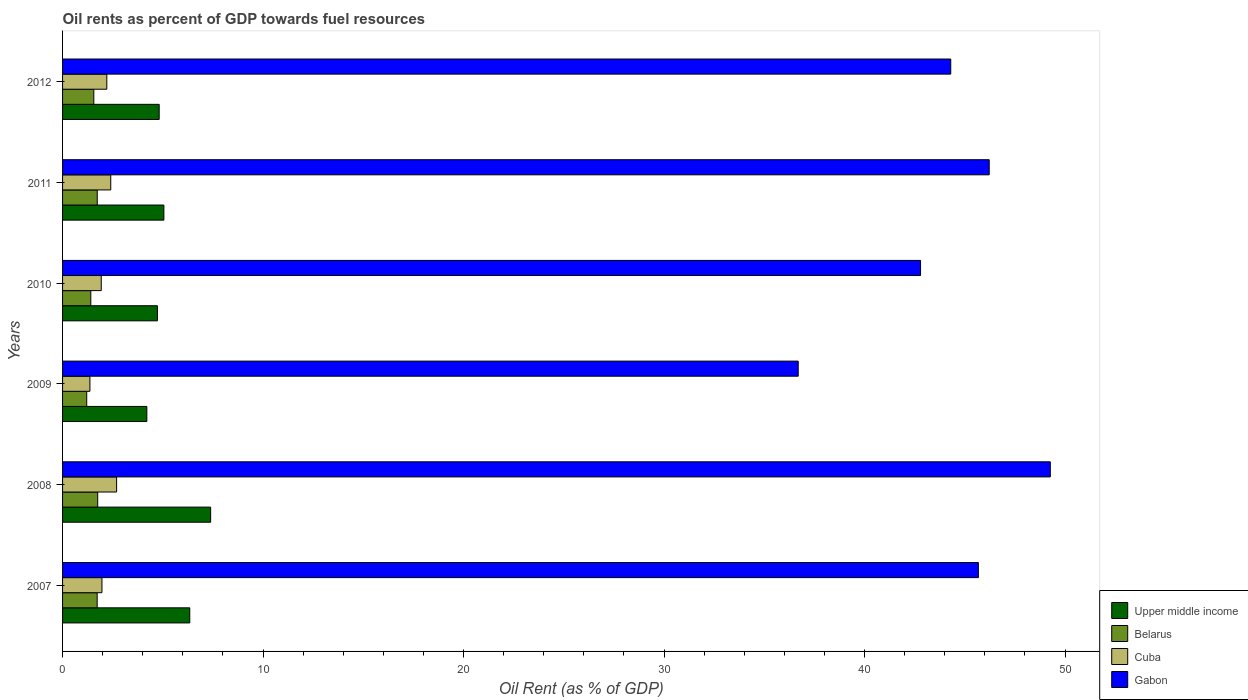How many groups of bars are there?
Offer a terse response. 6. What is the oil rent in Upper middle income in 2010?
Your answer should be very brief. 4.73. Across all years, what is the maximum oil rent in Belarus?
Give a very brief answer. 1.75. Across all years, what is the minimum oil rent in Upper middle income?
Your response must be concise. 4.2. In which year was the oil rent in Cuba maximum?
Offer a very short reply. 2008. What is the total oil rent in Belarus in the graph?
Your response must be concise. 9.38. What is the difference between the oil rent in Belarus in 2010 and that in 2012?
Your answer should be very brief. -0.15. What is the difference between the oil rent in Cuba in 2011 and the oil rent in Belarus in 2008?
Your answer should be very brief. 0.65. What is the average oil rent in Gabon per year?
Your answer should be very brief. 44.16. In the year 2008, what is the difference between the oil rent in Upper middle income and oil rent in Gabon?
Offer a terse response. -41.88. What is the ratio of the oil rent in Gabon in 2009 to that in 2012?
Your answer should be very brief. 0.83. Is the oil rent in Cuba in 2011 less than that in 2012?
Provide a succinct answer. No. What is the difference between the highest and the second highest oil rent in Gabon?
Keep it short and to the point. 3.05. What is the difference between the highest and the lowest oil rent in Upper middle income?
Provide a succinct answer. 3.18. In how many years, is the oil rent in Cuba greater than the average oil rent in Cuba taken over all years?
Provide a short and direct response. 3. Is it the case that in every year, the sum of the oil rent in Cuba and oil rent in Belarus is greater than the sum of oil rent in Upper middle income and oil rent in Gabon?
Make the answer very short. No. What does the 2nd bar from the top in 2007 represents?
Provide a short and direct response. Cuba. What does the 4th bar from the bottom in 2012 represents?
Keep it short and to the point. Gabon. Are all the bars in the graph horizontal?
Offer a terse response. Yes. What is the difference between two consecutive major ticks on the X-axis?
Keep it short and to the point. 10. Are the values on the major ticks of X-axis written in scientific E-notation?
Offer a terse response. No. Does the graph contain any zero values?
Ensure brevity in your answer.  No. Where does the legend appear in the graph?
Your answer should be compact. Bottom right. How are the legend labels stacked?
Provide a short and direct response. Vertical. What is the title of the graph?
Provide a short and direct response. Oil rents as percent of GDP towards fuel resources. Does "New Zealand" appear as one of the legend labels in the graph?
Ensure brevity in your answer.  No. What is the label or title of the X-axis?
Make the answer very short. Oil Rent (as % of GDP). What is the label or title of the Y-axis?
Offer a very short reply. Years. What is the Oil Rent (as % of GDP) in Upper middle income in 2007?
Give a very brief answer. 6.34. What is the Oil Rent (as % of GDP) of Belarus in 2007?
Give a very brief answer. 1.73. What is the Oil Rent (as % of GDP) in Cuba in 2007?
Your answer should be compact. 1.96. What is the Oil Rent (as % of GDP) in Gabon in 2007?
Keep it short and to the point. 45.68. What is the Oil Rent (as % of GDP) of Upper middle income in 2008?
Give a very brief answer. 7.39. What is the Oil Rent (as % of GDP) in Belarus in 2008?
Your answer should be compact. 1.75. What is the Oil Rent (as % of GDP) in Cuba in 2008?
Your answer should be very brief. 2.7. What is the Oil Rent (as % of GDP) in Gabon in 2008?
Provide a succinct answer. 49.26. What is the Oil Rent (as % of GDP) in Upper middle income in 2009?
Your answer should be very brief. 4.2. What is the Oil Rent (as % of GDP) in Belarus in 2009?
Offer a terse response. 1.2. What is the Oil Rent (as % of GDP) of Cuba in 2009?
Your response must be concise. 1.36. What is the Oil Rent (as % of GDP) in Gabon in 2009?
Give a very brief answer. 36.69. What is the Oil Rent (as % of GDP) in Upper middle income in 2010?
Provide a succinct answer. 4.73. What is the Oil Rent (as % of GDP) in Belarus in 2010?
Make the answer very short. 1.41. What is the Oil Rent (as % of GDP) in Cuba in 2010?
Provide a succinct answer. 1.93. What is the Oil Rent (as % of GDP) in Gabon in 2010?
Provide a short and direct response. 42.79. What is the Oil Rent (as % of GDP) in Upper middle income in 2011?
Keep it short and to the point. 5.05. What is the Oil Rent (as % of GDP) in Belarus in 2011?
Offer a very short reply. 1.73. What is the Oil Rent (as % of GDP) in Cuba in 2011?
Your response must be concise. 2.4. What is the Oil Rent (as % of GDP) of Gabon in 2011?
Provide a short and direct response. 46.22. What is the Oil Rent (as % of GDP) in Upper middle income in 2012?
Offer a very short reply. 4.82. What is the Oil Rent (as % of GDP) in Belarus in 2012?
Keep it short and to the point. 1.56. What is the Oil Rent (as % of GDP) in Cuba in 2012?
Offer a terse response. 2.21. What is the Oil Rent (as % of GDP) in Gabon in 2012?
Your answer should be very brief. 44.3. Across all years, what is the maximum Oil Rent (as % of GDP) in Upper middle income?
Your answer should be compact. 7.39. Across all years, what is the maximum Oil Rent (as % of GDP) of Belarus?
Offer a terse response. 1.75. Across all years, what is the maximum Oil Rent (as % of GDP) of Cuba?
Your response must be concise. 2.7. Across all years, what is the maximum Oil Rent (as % of GDP) in Gabon?
Provide a short and direct response. 49.26. Across all years, what is the minimum Oil Rent (as % of GDP) in Upper middle income?
Keep it short and to the point. 4.2. Across all years, what is the minimum Oil Rent (as % of GDP) in Belarus?
Provide a succinct answer. 1.2. Across all years, what is the minimum Oil Rent (as % of GDP) in Cuba?
Keep it short and to the point. 1.36. Across all years, what is the minimum Oil Rent (as % of GDP) in Gabon?
Offer a terse response. 36.69. What is the total Oil Rent (as % of GDP) of Upper middle income in the graph?
Your response must be concise. 32.54. What is the total Oil Rent (as % of GDP) of Belarus in the graph?
Ensure brevity in your answer.  9.38. What is the total Oil Rent (as % of GDP) of Cuba in the graph?
Make the answer very short. 12.56. What is the total Oil Rent (as % of GDP) in Gabon in the graph?
Provide a short and direct response. 264.94. What is the difference between the Oil Rent (as % of GDP) in Upper middle income in 2007 and that in 2008?
Make the answer very short. -1.04. What is the difference between the Oil Rent (as % of GDP) of Belarus in 2007 and that in 2008?
Provide a short and direct response. -0.03. What is the difference between the Oil Rent (as % of GDP) in Cuba in 2007 and that in 2008?
Your response must be concise. -0.73. What is the difference between the Oil Rent (as % of GDP) of Gabon in 2007 and that in 2008?
Your answer should be very brief. -3.59. What is the difference between the Oil Rent (as % of GDP) of Upper middle income in 2007 and that in 2009?
Offer a terse response. 2.14. What is the difference between the Oil Rent (as % of GDP) in Belarus in 2007 and that in 2009?
Your answer should be compact. 0.52. What is the difference between the Oil Rent (as % of GDP) of Cuba in 2007 and that in 2009?
Your answer should be very brief. 0.6. What is the difference between the Oil Rent (as % of GDP) in Gabon in 2007 and that in 2009?
Offer a terse response. 8.99. What is the difference between the Oil Rent (as % of GDP) in Upper middle income in 2007 and that in 2010?
Offer a very short reply. 1.61. What is the difference between the Oil Rent (as % of GDP) of Belarus in 2007 and that in 2010?
Provide a succinct answer. 0.32. What is the difference between the Oil Rent (as % of GDP) in Cuba in 2007 and that in 2010?
Give a very brief answer. 0.03. What is the difference between the Oil Rent (as % of GDP) of Gabon in 2007 and that in 2010?
Provide a succinct answer. 2.88. What is the difference between the Oil Rent (as % of GDP) of Upper middle income in 2007 and that in 2011?
Provide a short and direct response. 1.29. What is the difference between the Oil Rent (as % of GDP) in Belarus in 2007 and that in 2011?
Ensure brevity in your answer.  -0. What is the difference between the Oil Rent (as % of GDP) in Cuba in 2007 and that in 2011?
Your answer should be compact. -0.44. What is the difference between the Oil Rent (as % of GDP) in Gabon in 2007 and that in 2011?
Offer a very short reply. -0.54. What is the difference between the Oil Rent (as % of GDP) of Upper middle income in 2007 and that in 2012?
Offer a terse response. 1.52. What is the difference between the Oil Rent (as % of GDP) of Belarus in 2007 and that in 2012?
Ensure brevity in your answer.  0.17. What is the difference between the Oil Rent (as % of GDP) in Cuba in 2007 and that in 2012?
Provide a succinct answer. -0.24. What is the difference between the Oil Rent (as % of GDP) in Gabon in 2007 and that in 2012?
Make the answer very short. 1.38. What is the difference between the Oil Rent (as % of GDP) in Upper middle income in 2008 and that in 2009?
Ensure brevity in your answer.  3.18. What is the difference between the Oil Rent (as % of GDP) in Belarus in 2008 and that in 2009?
Make the answer very short. 0.55. What is the difference between the Oil Rent (as % of GDP) of Cuba in 2008 and that in 2009?
Keep it short and to the point. 1.33. What is the difference between the Oil Rent (as % of GDP) of Gabon in 2008 and that in 2009?
Offer a very short reply. 12.57. What is the difference between the Oil Rent (as % of GDP) of Upper middle income in 2008 and that in 2010?
Keep it short and to the point. 2.65. What is the difference between the Oil Rent (as % of GDP) in Belarus in 2008 and that in 2010?
Make the answer very short. 0.35. What is the difference between the Oil Rent (as % of GDP) of Cuba in 2008 and that in 2010?
Make the answer very short. 0.77. What is the difference between the Oil Rent (as % of GDP) of Gabon in 2008 and that in 2010?
Your answer should be very brief. 6.47. What is the difference between the Oil Rent (as % of GDP) of Upper middle income in 2008 and that in 2011?
Provide a short and direct response. 2.33. What is the difference between the Oil Rent (as % of GDP) in Belarus in 2008 and that in 2011?
Provide a succinct answer. 0.02. What is the difference between the Oil Rent (as % of GDP) in Cuba in 2008 and that in 2011?
Keep it short and to the point. 0.29. What is the difference between the Oil Rent (as % of GDP) of Gabon in 2008 and that in 2011?
Provide a short and direct response. 3.05. What is the difference between the Oil Rent (as % of GDP) in Upper middle income in 2008 and that in 2012?
Give a very brief answer. 2.57. What is the difference between the Oil Rent (as % of GDP) of Belarus in 2008 and that in 2012?
Provide a short and direct response. 0.19. What is the difference between the Oil Rent (as % of GDP) of Cuba in 2008 and that in 2012?
Offer a terse response. 0.49. What is the difference between the Oil Rent (as % of GDP) in Gabon in 2008 and that in 2012?
Your response must be concise. 4.97. What is the difference between the Oil Rent (as % of GDP) in Upper middle income in 2009 and that in 2010?
Make the answer very short. -0.53. What is the difference between the Oil Rent (as % of GDP) of Belarus in 2009 and that in 2010?
Give a very brief answer. -0.2. What is the difference between the Oil Rent (as % of GDP) of Cuba in 2009 and that in 2010?
Offer a very short reply. -0.57. What is the difference between the Oil Rent (as % of GDP) in Gabon in 2009 and that in 2010?
Your answer should be compact. -6.1. What is the difference between the Oil Rent (as % of GDP) in Upper middle income in 2009 and that in 2011?
Provide a succinct answer. -0.85. What is the difference between the Oil Rent (as % of GDP) in Belarus in 2009 and that in 2011?
Keep it short and to the point. -0.52. What is the difference between the Oil Rent (as % of GDP) of Cuba in 2009 and that in 2011?
Offer a terse response. -1.04. What is the difference between the Oil Rent (as % of GDP) in Gabon in 2009 and that in 2011?
Offer a very short reply. -9.53. What is the difference between the Oil Rent (as % of GDP) in Upper middle income in 2009 and that in 2012?
Provide a succinct answer. -0.62. What is the difference between the Oil Rent (as % of GDP) of Belarus in 2009 and that in 2012?
Provide a short and direct response. -0.35. What is the difference between the Oil Rent (as % of GDP) in Cuba in 2009 and that in 2012?
Keep it short and to the point. -0.84. What is the difference between the Oil Rent (as % of GDP) of Gabon in 2009 and that in 2012?
Your answer should be compact. -7.61. What is the difference between the Oil Rent (as % of GDP) in Upper middle income in 2010 and that in 2011?
Your answer should be very brief. -0.32. What is the difference between the Oil Rent (as % of GDP) of Belarus in 2010 and that in 2011?
Keep it short and to the point. -0.32. What is the difference between the Oil Rent (as % of GDP) of Cuba in 2010 and that in 2011?
Provide a succinct answer. -0.47. What is the difference between the Oil Rent (as % of GDP) of Gabon in 2010 and that in 2011?
Your answer should be very brief. -3.42. What is the difference between the Oil Rent (as % of GDP) in Upper middle income in 2010 and that in 2012?
Make the answer very short. -0.09. What is the difference between the Oil Rent (as % of GDP) of Belarus in 2010 and that in 2012?
Your response must be concise. -0.15. What is the difference between the Oil Rent (as % of GDP) in Cuba in 2010 and that in 2012?
Your answer should be very brief. -0.28. What is the difference between the Oil Rent (as % of GDP) in Gabon in 2010 and that in 2012?
Make the answer very short. -1.51. What is the difference between the Oil Rent (as % of GDP) in Upper middle income in 2011 and that in 2012?
Your answer should be compact. 0.23. What is the difference between the Oil Rent (as % of GDP) of Belarus in 2011 and that in 2012?
Your response must be concise. 0.17. What is the difference between the Oil Rent (as % of GDP) of Cuba in 2011 and that in 2012?
Offer a terse response. 0.2. What is the difference between the Oil Rent (as % of GDP) of Gabon in 2011 and that in 2012?
Ensure brevity in your answer.  1.92. What is the difference between the Oil Rent (as % of GDP) in Upper middle income in 2007 and the Oil Rent (as % of GDP) in Belarus in 2008?
Keep it short and to the point. 4.59. What is the difference between the Oil Rent (as % of GDP) in Upper middle income in 2007 and the Oil Rent (as % of GDP) in Cuba in 2008?
Ensure brevity in your answer.  3.65. What is the difference between the Oil Rent (as % of GDP) of Upper middle income in 2007 and the Oil Rent (as % of GDP) of Gabon in 2008?
Provide a short and direct response. -42.92. What is the difference between the Oil Rent (as % of GDP) in Belarus in 2007 and the Oil Rent (as % of GDP) in Cuba in 2008?
Keep it short and to the point. -0.97. What is the difference between the Oil Rent (as % of GDP) of Belarus in 2007 and the Oil Rent (as % of GDP) of Gabon in 2008?
Your response must be concise. -47.54. What is the difference between the Oil Rent (as % of GDP) of Cuba in 2007 and the Oil Rent (as % of GDP) of Gabon in 2008?
Offer a very short reply. -47.3. What is the difference between the Oil Rent (as % of GDP) in Upper middle income in 2007 and the Oil Rent (as % of GDP) in Belarus in 2009?
Your answer should be compact. 5.14. What is the difference between the Oil Rent (as % of GDP) in Upper middle income in 2007 and the Oil Rent (as % of GDP) in Cuba in 2009?
Offer a terse response. 4.98. What is the difference between the Oil Rent (as % of GDP) of Upper middle income in 2007 and the Oil Rent (as % of GDP) of Gabon in 2009?
Offer a terse response. -30.35. What is the difference between the Oil Rent (as % of GDP) in Belarus in 2007 and the Oil Rent (as % of GDP) in Cuba in 2009?
Offer a terse response. 0.36. What is the difference between the Oil Rent (as % of GDP) in Belarus in 2007 and the Oil Rent (as % of GDP) in Gabon in 2009?
Your answer should be compact. -34.97. What is the difference between the Oil Rent (as % of GDP) of Cuba in 2007 and the Oil Rent (as % of GDP) of Gabon in 2009?
Provide a succinct answer. -34.73. What is the difference between the Oil Rent (as % of GDP) in Upper middle income in 2007 and the Oil Rent (as % of GDP) in Belarus in 2010?
Provide a short and direct response. 4.94. What is the difference between the Oil Rent (as % of GDP) of Upper middle income in 2007 and the Oil Rent (as % of GDP) of Cuba in 2010?
Keep it short and to the point. 4.41. What is the difference between the Oil Rent (as % of GDP) of Upper middle income in 2007 and the Oil Rent (as % of GDP) of Gabon in 2010?
Your answer should be compact. -36.45. What is the difference between the Oil Rent (as % of GDP) in Belarus in 2007 and the Oil Rent (as % of GDP) in Cuba in 2010?
Provide a succinct answer. -0.2. What is the difference between the Oil Rent (as % of GDP) in Belarus in 2007 and the Oil Rent (as % of GDP) in Gabon in 2010?
Your answer should be very brief. -41.07. What is the difference between the Oil Rent (as % of GDP) in Cuba in 2007 and the Oil Rent (as % of GDP) in Gabon in 2010?
Keep it short and to the point. -40.83. What is the difference between the Oil Rent (as % of GDP) in Upper middle income in 2007 and the Oil Rent (as % of GDP) in Belarus in 2011?
Your answer should be compact. 4.61. What is the difference between the Oil Rent (as % of GDP) of Upper middle income in 2007 and the Oil Rent (as % of GDP) of Cuba in 2011?
Your answer should be very brief. 3.94. What is the difference between the Oil Rent (as % of GDP) of Upper middle income in 2007 and the Oil Rent (as % of GDP) of Gabon in 2011?
Give a very brief answer. -39.87. What is the difference between the Oil Rent (as % of GDP) in Belarus in 2007 and the Oil Rent (as % of GDP) in Cuba in 2011?
Your response must be concise. -0.68. What is the difference between the Oil Rent (as % of GDP) of Belarus in 2007 and the Oil Rent (as % of GDP) of Gabon in 2011?
Provide a short and direct response. -44.49. What is the difference between the Oil Rent (as % of GDP) of Cuba in 2007 and the Oil Rent (as % of GDP) of Gabon in 2011?
Your answer should be very brief. -44.25. What is the difference between the Oil Rent (as % of GDP) of Upper middle income in 2007 and the Oil Rent (as % of GDP) of Belarus in 2012?
Keep it short and to the point. 4.79. What is the difference between the Oil Rent (as % of GDP) of Upper middle income in 2007 and the Oil Rent (as % of GDP) of Cuba in 2012?
Provide a short and direct response. 4.14. What is the difference between the Oil Rent (as % of GDP) in Upper middle income in 2007 and the Oil Rent (as % of GDP) in Gabon in 2012?
Keep it short and to the point. -37.95. What is the difference between the Oil Rent (as % of GDP) of Belarus in 2007 and the Oil Rent (as % of GDP) of Cuba in 2012?
Provide a short and direct response. -0.48. What is the difference between the Oil Rent (as % of GDP) of Belarus in 2007 and the Oil Rent (as % of GDP) of Gabon in 2012?
Your answer should be compact. -42.57. What is the difference between the Oil Rent (as % of GDP) of Cuba in 2007 and the Oil Rent (as % of GDP) of Gabon in 2012?
Your answer should be compact. -42.33. What is the difference between the Oil Rent (as % of GDP) of Upper middle income in 2008 and the Oil Rent (as % of GDP) of Belarus in 2009?
Give a very brief answer. 6.18. What is the difference between the Oil Rent (as % of GDP) of Upper middle income in 2008 and the Oil Rent (as % of GDP) of Cuba in 2009?
Offer a terse response. 6.02. What is the difference between the Oil Rent (as % of GDP) in Upper middle income in 2008 and the Oil Rent (as % of GDP) in Gabon in 2009?
Offer a very short reply. -29.31. What is the difference between the Oil Rent (as % of GDP) in Belarus in 2008 and the Oil Rent (as % of GDP) in Cuba in 2009?
Provide a succinct answer. 0.39. What is the difference between the Oil Rent (as % of GDP) of Belarus in 2008 and the Oil Rent (as % of GDP) of Gabon in 2009?
Your answer should be compact. -34.94. What is the difference between the Oil Rent (as % of GDP) in Cuba in 2008 and the Oil Rent (as % of GDP) in Gabon in 2009?
Provide a short and direct response. -34. What is the difference between the Oil Rent (as % of GDP) in Upper middle income in 2008 and the Oil Rent (as % of GDP) in Belarus in 2010?
Keep it short and to the point. 5.98. What is the difference between the Oil Rent (as % of GDP) in Upper middle income in 2008 and the Oil Rent (as % of GDP) in Cuba in 2010?
Your response must be concise. 5.46. What is the difference between the Oil Rent (as % of GDP) of Upper middle income in 2008 and the Oil Rent (as % of GDP) of Gabon in 2010?
Keep it short and to the point. -35.41. What is the difference between the Oil Rent (as % of GDP) of Belarus in 2008 and the Oil Rent (as % of GDP) of Cuba in 2010?
Make the answer very short. -0.18. What is the difference between the Oil Rent (as % of GDP) in Belarus in 2008 and the Oil Rent (as % of GDP) in Gabon in 2010?
Your answer should be compact. -41.04. What is the difference between the Oil Rent (as % of GDP) of Cuba in 2008 and the Oil Rent (as % of GDP) of Gabon in 2010?
Offer a very short reply. -40.1. What is the difference between the Oil Rent (as % of GDP) of Upper middle income in 2008 and the Oil Rent (as % of GDP) of Belarus in 2011?
Offer a terse response. 5.66. What is the difference between the Oil Rent (as % of GDP) of Upper middle income in 2008 and the Oil Rent (as % of GDP) of Cuba in 2011?
Offer a very short reply. 4.98. What is the difference between the Oil Rent (as % of GDP) in Upper middle income in 2008 and the Oil Rent (as % of GDP) in Gabon in 2011?
Provide a succinct answer. -38.83. What is the difference between the Oil Rent (as % of GDP) of Belarus in 2008 and the Oil Rent (as % of GDP) of Cuba in 2011?
Offer a terse response. -0.65. What is the difference between the Oil Rent (as % of GDP) of Belarus in 2008 and the Oil Rent (as % of GDP) of Gabon in 2011?
Ensure brevity in your answer.  -44.46. What is the difference between the Oil Rent (as % of GDP) in Cuba in 2008 and the Oil Rent (as % of GDP) in Gabon in 2011?
Provide a succinct answer. -43.52. What is the difference between the Oil Rent (as % of GDP) in Upper middle income in 2008 and the Oil Rent (as % of GDP) in Belarus in 2012?
Your response must be concise. 5.83. What is the difference between the Oil Rent (as % of GDP) of Upper middle income in 2008 and the Oil Rent (as % of GDP) of Cuba in 2012?
Your answer should be very brief. 5.18. What is the difference between the Oil Rent (as % of GDP) of Upper middle income in 2008 and the Oil Rent (as % of GDP) of Gabon in 2012?
Your response must be concise. -36.91. What is the difference between the Oil Rent (as % of GDP) of Belarus in 2008 and the Oil Rent (as % of GDP) of Cuba in 2012?
Ensure brevity in your answer.  -0.45. What is the difference between the Oil Rent (as % of GDP) of Belarus in 2008 and the Oil Rent (as % of GDP) of Gabon in 2012?
Offer a terse response. -42.55. What is the difference between the Oil Rent (as % of GDP) in Cuba in 2008 and the Oil Rent (as % of GDP) in Gabon in 2012?
Your response must be concise. -41.6. What is the difference between the Oil Rent (as % of GDP) of Upper middle income in 2009 and the Oil Rent (as % of GDP) of Belarus in 2010?
Keep it short and to the point. 2.8. What is the difference between the Oil Rent (as % of GDP) in Upper middle income in 2009 and the Oil Rent (as % of GDP) in Cuba in 2010?
Your answer should be very brief. 2.27. What is the difference between the Oil Rent (as % of GDP) of Upper middle income in 2009 and the Oil Rent (as % of GDP) of Gabon in 2010?
Make the answer very short. -38.59. What is the difference between the Oil Rent (as % of GDP) of Belarus in 2009 and the Oil Rent (as % of GDP) of Cuba in 2010?
Provide a short and direct response. -0.72. What is the difference between the Oil Rent (as % of GDP) in Belarus in 2009 and the Oil Rent (as % of GDP) in Gabon in 2010?
Make the answer very short. -41.59. What is the difference between the Oil Rent (as % of GDP) in Cuba in 2009 and the Oil Rent (as % of GDP) in Gabon in 2010?
Provide a succinct answer. -41.43. What is the difference between the Oil Rent (as % of GDP) of Upper middle income in 2009 and the Oil Rent (as % of GDP) of Belarus in 2011?
Your answer should be compact. 2.47. What is the difference between the Oil Rent (as % of GDP) in Upper middle income in 2009 and the Oil Rent (as % of GDP) in Cuba in 2011?
Offer a very short reply. 1.8. What is the difference between the Oil Rent (as % of GDP) in Upper middle income in 2009 and the Oil Rent (as % of GDP) in Gabon in 2011?
Offer a very short reply. -42.01. What is the difference between the Oil Rent (as % of GDP) of Belarus in 2009 and the Oil Rent (as % of GDP) of Cuba in 2011?
Your answer should be compact. -1.2. What is the difference between the Oil Rent (as % of GDP) in Belarus in 2009 and the Oil Rent (as % of GDP) in Gabon in 2011?
Your answer should be compact. -45.01. What is the difference between the Oil Rent (as % of GDP) of Cuba in 2009 and the Oil Rent (as % of GDP) of Gabon in 2011?
Your answer should be very brief. -44.85. What is the difference between the Oil Rent (as % of GDP) in Upper middle income in 2009 and the Oil Rent (as % of GDP) in Belarus in 2012?
Keep it short and to the point. 2.64. What is the difference between the Oil Rent (as % of GDP) in Upper middle income in 2009 and the Oil Rent (as % of GDP) in Cuba in 2012?
Offer a terse response. 2. What is the difference between the Oil Rent (as % of GDP) in Upper middle income in 2009 and the Oil Rent (as % of GDP) in Gabon in 2012?
Ensure brevity in your answer.  -40.1. What is the difference between the Oil Rent (as % of GDP) of Belarus in 2009 and the Oil Rent (as % of GDP) of Cuba in 2012?
Provide a succinct answer. -1. What is the difference between the Oil Rent (as % of GDP) in Belarus in 2009 and the Oil Rent (as % of GDP) in Gabon in 2012?
Give a very brief answer. -43.09. What is the difference between the Oil Rent (as % of GDP) in Cuba in 2009 and the Oil Rent (as % of GDP) in Gabon in 2012?
Keep it short and to the point. -42.93. What is the difference between the Oil Rent (as % of GDP) in Upper middle income in 2010 and the Oil Rent (as % of GDP) in Belarus in 2011?
Your answer should be very brief. 3. What is the difference between the Oil Rent (as % of GDP) in Upper middle income in 2010 and the Oil Rent (as % of GDP) in Cuba in 2011?
Your answer should be compact. 2.33. What is the difference between the Oil Rent (as % of GDP) in Upper middle income in 2010 and the Oil Rent (as % of GDP) in Gabon in 2011?
Keep it short and to the point. -41.49. What is the difference between the Oil Rent (as % of GDP) of Belarus in 2010 and the Oil Rent (as % of GDP) of Cuba in 2011?
Offer a very short reply. -1. What is the difference between the Oil Rent (as % of GDP) of Belarus in 2010 and the Oil Rent (as % of GDP) of Gabon in 2011?
Ensure brevity in your answer.  -44.81. What is the difference between the Oil Rent (as % of GDP) in Cuba in 2010 and the Oil Rent (as % of GDP) in Gabon in 2011?
Your answer should be very brief. -44.29. What is the difference between the Oil Rent (as % of GDP) of Upper middle income in 2010 and the Oil Rent (as % of GDP) of Belarus in 2012?
Offer a very short reply. 3.17. What is the difference between the Oil Rent (as % of GDP) of Upper middle income in 2010 and the Oil Rent (as % of GDP) of Cuba in 2012?
Give a very brief answer. 2.52. What is the difference between the Oil Rent (as % of GDP) in Upper middle income in 2010 and the Oil Rent (as % of GDP) in Gabon in 2012?
Make the answer very short. -39.57. What is the difference between the Oil Rent (as % of GDP) of Belarus in 2010 and the Oil Rent (as % of GDP) of Cuba in 2012?
Offer a terse response. -0.8. What is the difference between the Oil Rent (as % of GDP) of Belarus in 2010 and the Oil Rent (as % of GDP) of Gabon in 2012?
Offer a terse response. -42.89. What is the difference between the Oil Rent (as % of GDP) in Cuba in 2010 and the Oil Rent (as % of GDP) in Gabon in 2012?
Ensure brevity in your answer.  -42.37. What is the difference between the Oil Rent (as % of GDP) of Upper middle income in 2011 and the Oil Rent (as % of GDP) of Belarus in 2012?
Provide a short and direct response. 3.49. What is the difference between the Oil Rent (as % of GDP) of Upper middle income in 2011 and the Oil Rent (as % of GDP) of Cuba in 2012?
Your response must be concise. 2.85. What is the difference between the Oil Rent (as % of GDP) of Upper middle income in 2011 and the Oil Rent (as % of GDP) of Gabon in 2012?
Offer a terse response. -39.25. What is the difference between the Oil Rent (as % of GDP) of Belarus in 2011 and the Oil Rent (as % of GDP) of Cuba in 2012?
Provide a succinct answer. -0.48. What is the difference between the Oil Rent (as % of GDP) in Belarus in 2011 and the Oil Rent (as % of GDP) in Gabon in 2012?
Your answer should be compact. -42.57. What is the difference between the Oil Rent (as % of GDP) of Cuba in 2011 and the Oil Rent (as % of GDP) of Gabon in 2012?
Your answer should be very brief. -41.9. What is the average Oil Rent (as % of GDP) in Upper middle income per year?
Provide a short and direct response. 5.42. What is the average Oil Rent (as % of GDP) in Belarus per year?
Provide a short and direct response. 1.56. What is the average Oil Rent (as % of GDP) in Cuba per year?
Offer a terse response. 2.09. What is the average Oil Rent (as % of GDP) in Gabon per year?
Your answer should be very brief. 44.16. In the year 2007, what is the difference between the Oil Rent (as % of GDP) in Upper middle income and Oil Rent (as % of GDP) in Belarus?
Keep it short and to the point. 4.62. In the year 2007, what is the difference between the Oil Rent (as % of GDP) of Upper middle income and Oil Rent (as % of GDP) of Cuba?
Offer a terse response. 4.38. In the year 2007, what is the difference between the Oil Rent (as % of GDP) in Upper middle income and Oil Rent (as % of GDP) in Gabon?
Keep it short and to the point. -39.33. In the year 2007, what is the difference between the Oil Rent (as % of GDP) of Belarus and Oil Rent (as % of GDP) of Cuba?
Keep it short and to the point. -0.24. In the year 2007, what is the difference between the Oil Rent (as % of GDP) of Belarus and Oil Rent (as % of GDP) of Gabon?
Give a very brief answer. -43.95. In the year 2007, what is the difference between the Oil Rent (as % of GDP) in Cuba and Oil Rent (as % of GDP) in Gabon?
Make the answer very short. -43.71. In the year 2008, what is the difference between the Oil Rent (as % of GDP) in Upper middle income and Oil Rent (as % of GDP) in Belarus?
Ensure brevity in your answer.  5.63. In the year 2008, what is the difference between the Oil Rent (as % of GDP) in Upper middle income and Oil Rent (as % of GDP) in Cuba?
Make the answer very short. 4.69. In the year 2008, what is the difference between the Oil Rent (as % of GDP) in Upper middle income and Oil Rent (as % of GDP) in Gabon?
Keep it short and to the point. -41.88. In the year 2008, what is the difference between the Oil Rent (as % of GDP) in Belarus and Oil Rent (as % of GDP) in Cuba?
Provide a succinct answer. -0.94. In the year 2008, what is the difference between the Oil Rent (as % of GDP) of Belarus and Oil Rent (as % of GDP) of Gabon?
Provide a succinct answer. -47.51. In the year 2008, what is the difference between the Oil Rent (as % of GDP) of Cuba and Oil Rent (as % of GDP) of Gabon?
Keep it short and to the point. -46.57. In the year 2009, what is the difference between the Oil Rent (as % of GDP) in Upper middle income and Oil Rent (as % of GDP) in Belarus?
Offer a terse response. 3. In the year 2009, what is the difference between the Oil Rent (as % of GDP) of Upper middle income and Oil Rent (as % of GDP) of Cuba?
Give a very brief answer. 2.84. In the year 2009, what is the difference between the Oil Rent (as % of GDP) of Upper middle income and Oil Rent (as % of GDP) of Gabon?
Give a very brief answer. -32.49. In the year 2009, what is the difference between the Oil Rent (as % of GDP) of Belarus and Oil Rent (as % of GDP) of Cuba?
Give a very brief answer. -0.16. In the year 2009, what is the difference between the Oil Rent (as % of GDP) in Belarus and Oil Rent (as % of GDP) in Gabon?
Give a very brief answer. -35.49. In the year 2009, what is the difference between the Oil Rent (as % of GDP) of Cuba and Oil Rent (as % of GDP) of Gabon?
Your answer should be very brief. -35.33. In the year 2010, what is the difference between the Oil Rent (as % of GDP) in Upper middle income and Oil Rent (as % of GDP) in Belarus?
Give a very brief answer. 3.32. In the year 2010, what is the difference between the Oil Rent (as % of GDP) of Upper middle income and Oil Rent (as % of GDP) of Cuba?
Provide a succinct answer. 2.8. In the year 2010, what is the difference between the Oil Rent (as % of GDP) in Upper middle income and Oil Rent (as % of GDP) in Gabon?
Keep it short and to the point. -38.06. In the year 2010, what is the difference between the Oil Rent (as % of GDP) of Belarus and Oil Rent (as % of GDP) of Cuba?
Your answer should be very brief. -0.52. In the year 2010, what is the difference between the Oil Rent (as % of GDP) of Belarus and Oil Rent (as % of GDP) of Gabon?
Your response must be concise. -41.39. In the year 2010, what is the difference between the Oil Rent (as % of GDP) in Cuba and Oil Rent (as % of GDP) in Gabon?
Offer a terse response. -40.86. In the year 2011, what is the difference between the Oil Rent (as % of GDP) in Upper middle income and Oil Rent (as % of GDP) in Belarus?
Your answer should be very brief. 3.32. In the year 2011, what is the difference between the Oil Rent (as % of GDP) of Upper middle income and Oil Rent (as % of GDP) of Cuba?
Offer a terse response. 2.65. In the year 2011, what is the difference between the Oil Rent (as % of GDP) in Upper middle income and Oil Rent (as % of GDP) in Gabon?
Offer a very short reply. -41.16. In the year 2011, what is the difference between the Oil Rent (as % of GDP) in Belarus and Oil Rent (as % of GDP) in Cuba?
Make the answer very short. -0.67. In the year 2011, what is the difference between the Oil Rent (as % of GDP) in Belarus and Oil Rent (as % of GDP) in Gabon?
Give a very brief answer. -44.49. In the year 2011, what is the difference between the Oil Rent (as % of GDP) of Cuba and Oil Rent (as % of GDP) of Gabon?
Provide a succinct answer. -43.81. In the year 2012, what is the difference between the Oil Rent (as % of GDP) in Upper middle income and Oil Rent (as % of GDP) in Belarus?
Give a very brief answer. 3.26. In the year 2012, what is the difference between the Oil Rent (as % of GDP) of Upper middle income and Oil Rent (as % of GDP) of Cuba?
Keep it short and to the point. 2.61. In the year 2012, what is the difference between the Oil Rent (as % of GDP) in Upper middle income and Oil Rent (as % of GDP) in Gabon?
Ensure brevity in your answer.  -39.48. In the year 2012, what is the difference between the Oil Rent (as % of GDP) in Belarus and Oil Rent (as % of GDP) in Cuba?
Your answer should be compact. -0.65. In the year 2012, what is the difference between the Oil Rent (as % of GDP) of Belarus and Oil Rent (as % of GDP) of Gabon?
Provide a short and direct response. -42.74. In the year 2012, what is the difference between the Oil Rent (as % of GDP) of Cuba and Oil Rent (as % of GDP) of Gabon?
Provide a succinct answer. -42.09. What is the ratio of the Oil Rent (as % of GDP) in Upper middle income in 2007 to that in 2008?
Make the answer very short. 0.86. What is the ratio of the Oil Rent (as % of GDP) in Belarus in 2007 to that in 2008?
Offer a very short reply. 0.98. What is the ratio of the Oil Rent (as % of GDP) of Cuba in 2007 to that in 2008?
Ensure brevity in your answer.  0.73. What is the ratio of the Oil Rent (as % of GDP) of Gabon in 2007 to that in 2008?
Offer a terse response. 0.93. What is the ratio of the Oil Rent (as % of GDP) in Upper middle income in 2007 to that in 2009?
Provide a short and direct response. 1.51. What is the ratio of the Oil Rent (as % of GDP) in Belarus in 2007 to that in 2009?
Ensure brevity in your answer.  1.43. What is the ratio of the Oil Rent (as % of GDP) in Cuba in 2007 to that in 2009?
Make the answer very short. 1.44. What is the ratio of the Oil Rent (as % of GDP) in Gabon in 2007 to that in 2009?
Give a very brief answer. 1.24. What is the ratio of the Oil Rent (as % of GDP) of Upper middle income in 2007 to that in 2010?
Provide a succinct answer. 1.34. What is the ratio of the Oil Rent (as % of GDP) of Belarus in 2007 to that in 2010?
Provide a succinct answer. 1.23. What is the ratio of the Oil Rent (as % of GDP) in Cuba in 2007 to that in 2010?
Your response must be concise. 1.02. What is the ratio of the Oil Rent (as % of GDP) in Gabon in 2007 to that in 2010?
Provide a succinct answer. 1.07. What is the ratio of the Oil Rent (as % of GDP) of Upper middle income in 2007 to that in 2011?
Keep it short and to the point. 1.26. What is the ratio of the Oil Rent (as % of GDP) of Cuba in 2007 to that in 2011?
Offer a terse response. 0.82. What is the ratio of the Oil Rent (as % of GDP) of Gabon in 2007 to that in 2011?
Give a very brief answer. 0.99. What is the ratio of the Oil Rent (as % of GDP) in Upper middle income in 2007 to that in 2012?
Keep it short and to the point. 1.32. What is the ratio of the Oil Rent (as % of GDP) of Belarus in 2007 to that in 2012?
Give a very brief answer. 1.11. What is the ratio of the Oil Rent (as % of GDP) of Cuba in 2007 to that in 2012?
Your response must be concise. 0.89. What is the ratio of the Oil Rent (as % of GDP) in Gabon in 2007 to that in 2012?
Provide a succinct answer. 1.03. What is the ratio of the Oil Rent (as % of GDP) in Upper middle income in 2008 to that in 2009?
Give a very brief answer. 1.76. What is the ratio of the Oil Rent (as % of GDP) of Belarus in 2008 to that in 2009?
Your answer should be very brief. 1.45. What is the ratio of the Oil Rent (as % of GDP) of Cuba in 2008 to that in 2009?
Offer a terse response. 1.98. What is the ratio of the Oil Rent (as % of GDP) in Gabon in 2008 to that in 2009?
Your answer should be compact. 1.34. What is the ratio of the Oil Rent (as % of GDP) in Upper middle income in 2008 to that in 2010?
Provide a succinct answer. 1.56. What is the ratio of the Oil Rent (as % of GDP) of Belarus in 2008 to that in 2010?
Ensure brevity in your answer.  1.25. What is the ratio of the Oil Rent (as % of GDP) in Cuba in 2008 to that in 2010?
Your answer should be very brief. 1.4. What is the ratio of the Oil Rent (as % of GDP) in Gabon in 2008 to that in 2010?
Give a very brief answer. 1.15. What is the ratio of the Oil Rent (as % of GDP) of Upper middle income in 2008 to that in 2011?
Give a very brief answer. 1.46. What is the ratio of the Oil Rent (as % of GDP) of Belarus in 2008 to that in 2011?
Make the answer very short. 1.01. What is the ratio of the Oil Rent (as % of GDP) of Cuba in 2008 to that in 2011?
Offer a terse response. 1.12. What is the ratio of the Oil Rent (as % of GDP) in Gabon in 2008 to that in 2011?
Offer a very short reply. 1.07. What is the ratio of the Oil Rent (as % of GDP) in Upper middle income in 2008 to that in 2012?
Your answer should be very brief. 1.53. What is the ratio of the Oil Rent (as % of GDP) of Belarus in 2008 to that in 2012?
Give a very brief answer. 1.12. What is the ratio of the Oil Rent (as % of GDP) in Cuba in 2008 to that in 2012?
Keep it short and to the point. 1.22. What is the ratio of the Oil Rent (as % of GDP) of Gabon in 2008 to that in 2012?
Give a very brief answer. 1.11. What is the ratio of the Oil Rent (as % of GDP) of Upper middle income in 2009 to that in 2010?
Provide a short and direct response. 0.89. What is the ratio of the Oil Rent (as % of GDP) in Belarus in 2009 to that in 2010?
Provide a short and direct response. 0.86. What is the ratio of the Oil Rent (as % of GDP) of Cuba in 2009 to that in 2010?
Give a very brief answer. 0.71. What is the ratio of the Oil Rent (as % of GDP) in Gabon in 2009 to that in 2010?
Offer a terse response. 0.86. What is the ratio of the Oil Rent (as % of GDP) in Upper middle income in 2009 to that in 2011?
Provide a short and direct response. 0.83. What is the ratio of the Oil Rent (as % of GDP) in Belarus in 2009 to that in 2011?
Offer a very short reply. 0.7. What is the ratio of the Oil Rent (as % of GDP) of Cuba in 2009 to that in 2011?
Make the answer very short. 0.57. What is the ratio of the Oil Rent (as % of GDP) in Gabon in 2009 to that in 2011?
Offer a very short reply. 0.79. What is the ratio of the Oil Rent (as % of GDP) in Upper middle income in 2009 to that in 2012?
Make the answer very short. 0.87. What is the ratio of the Oil Rent (as % of GDP) in Belarus in 2009 to that in 2012?
Ensure brevity in your answer.  0.77. What is the ratio of the Oil Rent (as % of GDP) in Cuba in 2009 to that in 2012?
Your answer should be compact. 0.62. What is the ratio of the Oil Rent (as % of GDP) in Gabon in 2009 to that in 2012?
Give a very brief answer. 0.83. What is the ratio of the Oil Rent (as % of GDP) of Upper middle income in 2010 to that in 2011?
Keep it short and to the point. 0.94. What is the ratio of the Oil Rent (as % of GDP) in Belarus in 2010 to that in 2011?
Your response must be concise. 0.81. What is the ratio of the Oil Rent (as % of GDP) in Cuba in 2010 to that in 2011?
Provide a succinct answer. 0.8. What is the ratio of the Oil Rent (as % of GDP) in Gabon in 2010 to that in 2011?
Provide a short and direct response. 0.93. What is the ratio of the Oil Rent (as % of GDP) of Upper middle income in 2010 to that in 2012?
Give a very brief answer. 0.98. What is the ratio of the Oil Rent (as % of GDP) in Belarus in 2010 to that in 2012?
Offer a terse response. 0.9. What is the ratio of the Oil Rent (as % of GDP) of Cuba in 2010 to that in 2012?
Your response must be concise. 0.87. What is the ratio of the Oil Rent (as % of GDP) in Upper middle income in 2011 to that in 2012?
Offer a very short reply. 1.05. What is the ratio of the Oil Rent (as % of GDP) in Belarus in 2011 to that in 2012?
Your response must be concise. 1.11. What is the ratio of the Oil Rent (as % of GDP) of Cuba in 2011 to that in 2012?
Provide a succinct answer. 1.09. What is the ratio of the Oil Rent (as % of GDP) of Gabon in 2011 to that in 2012?
Your response must be concise. 1.04. What is the difference between the highest and the second highest Oil Rent (as % of GDP) of Upper middle income?
Give a very brief answer. 1.04. What is the difference between the highest and the second highest Oil Rent (as % of GDP) of Belarus?
Your answer should be compact. 0.02. What is the difference between the highest and the second highest Oil Rent (as % of GDP) in Cuba?
Provide a short and direct response. 0.29. What is the difference between the highest and the second highest Oil Rent (as % of GDP) of Gabon?
Offer a terse response. 3.05. What is the difference between the highest and the lowest Oil Rent (as % of GDP) in Upper middle income?
Offer a terse response. 3.18. What is the difference between the highest and the lowest Oil Rent (as % of GDP) in Belarus?
Offer a very short reply. 0.55. What is the difference between the highest and the lowest Oil Rent (as % of GDP) in Cuba?
Your answer should be very brief. 1.33. What is the difference between the highest and the lowest Oil Rent (as % of GDP) in Gabon?
Make the answer very short. 12.57. 